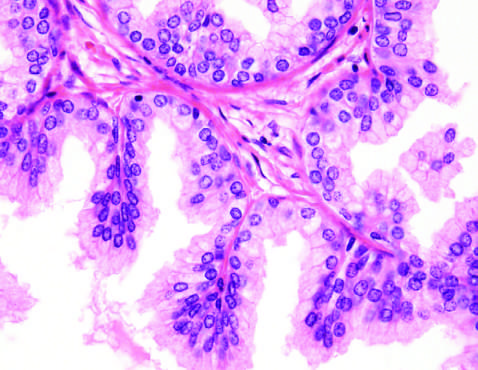what demonstrates a well-demarcated nodule at the right of the field, with a portion of urethra seen to the left?
Answer the question using a single word or phrase. Low-power photomicrograph 